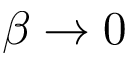<formula> <loc_0><loc_0><loc_500><loc_500>\beta \rightarrow 0</formula> 